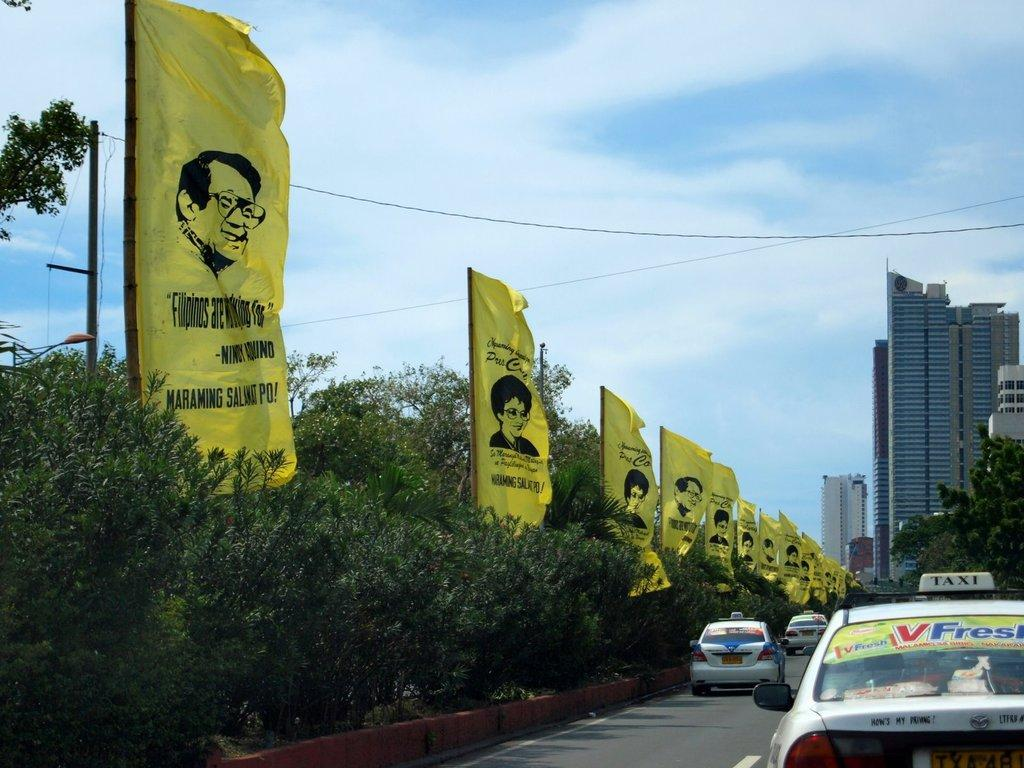<image>
Describe the image concisely. On the back of the Taxi it asks how's my driving. 